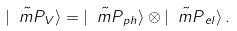<formula> <loc_0><loc_0><loc_500><loc_500>| \tilde { \ m P } _ { V } \rangle = | \tilde { \ m P } _ { p h } \rangle \otimes | \tilde { \ m P } _ { e l } \rangle \, .</formula> 